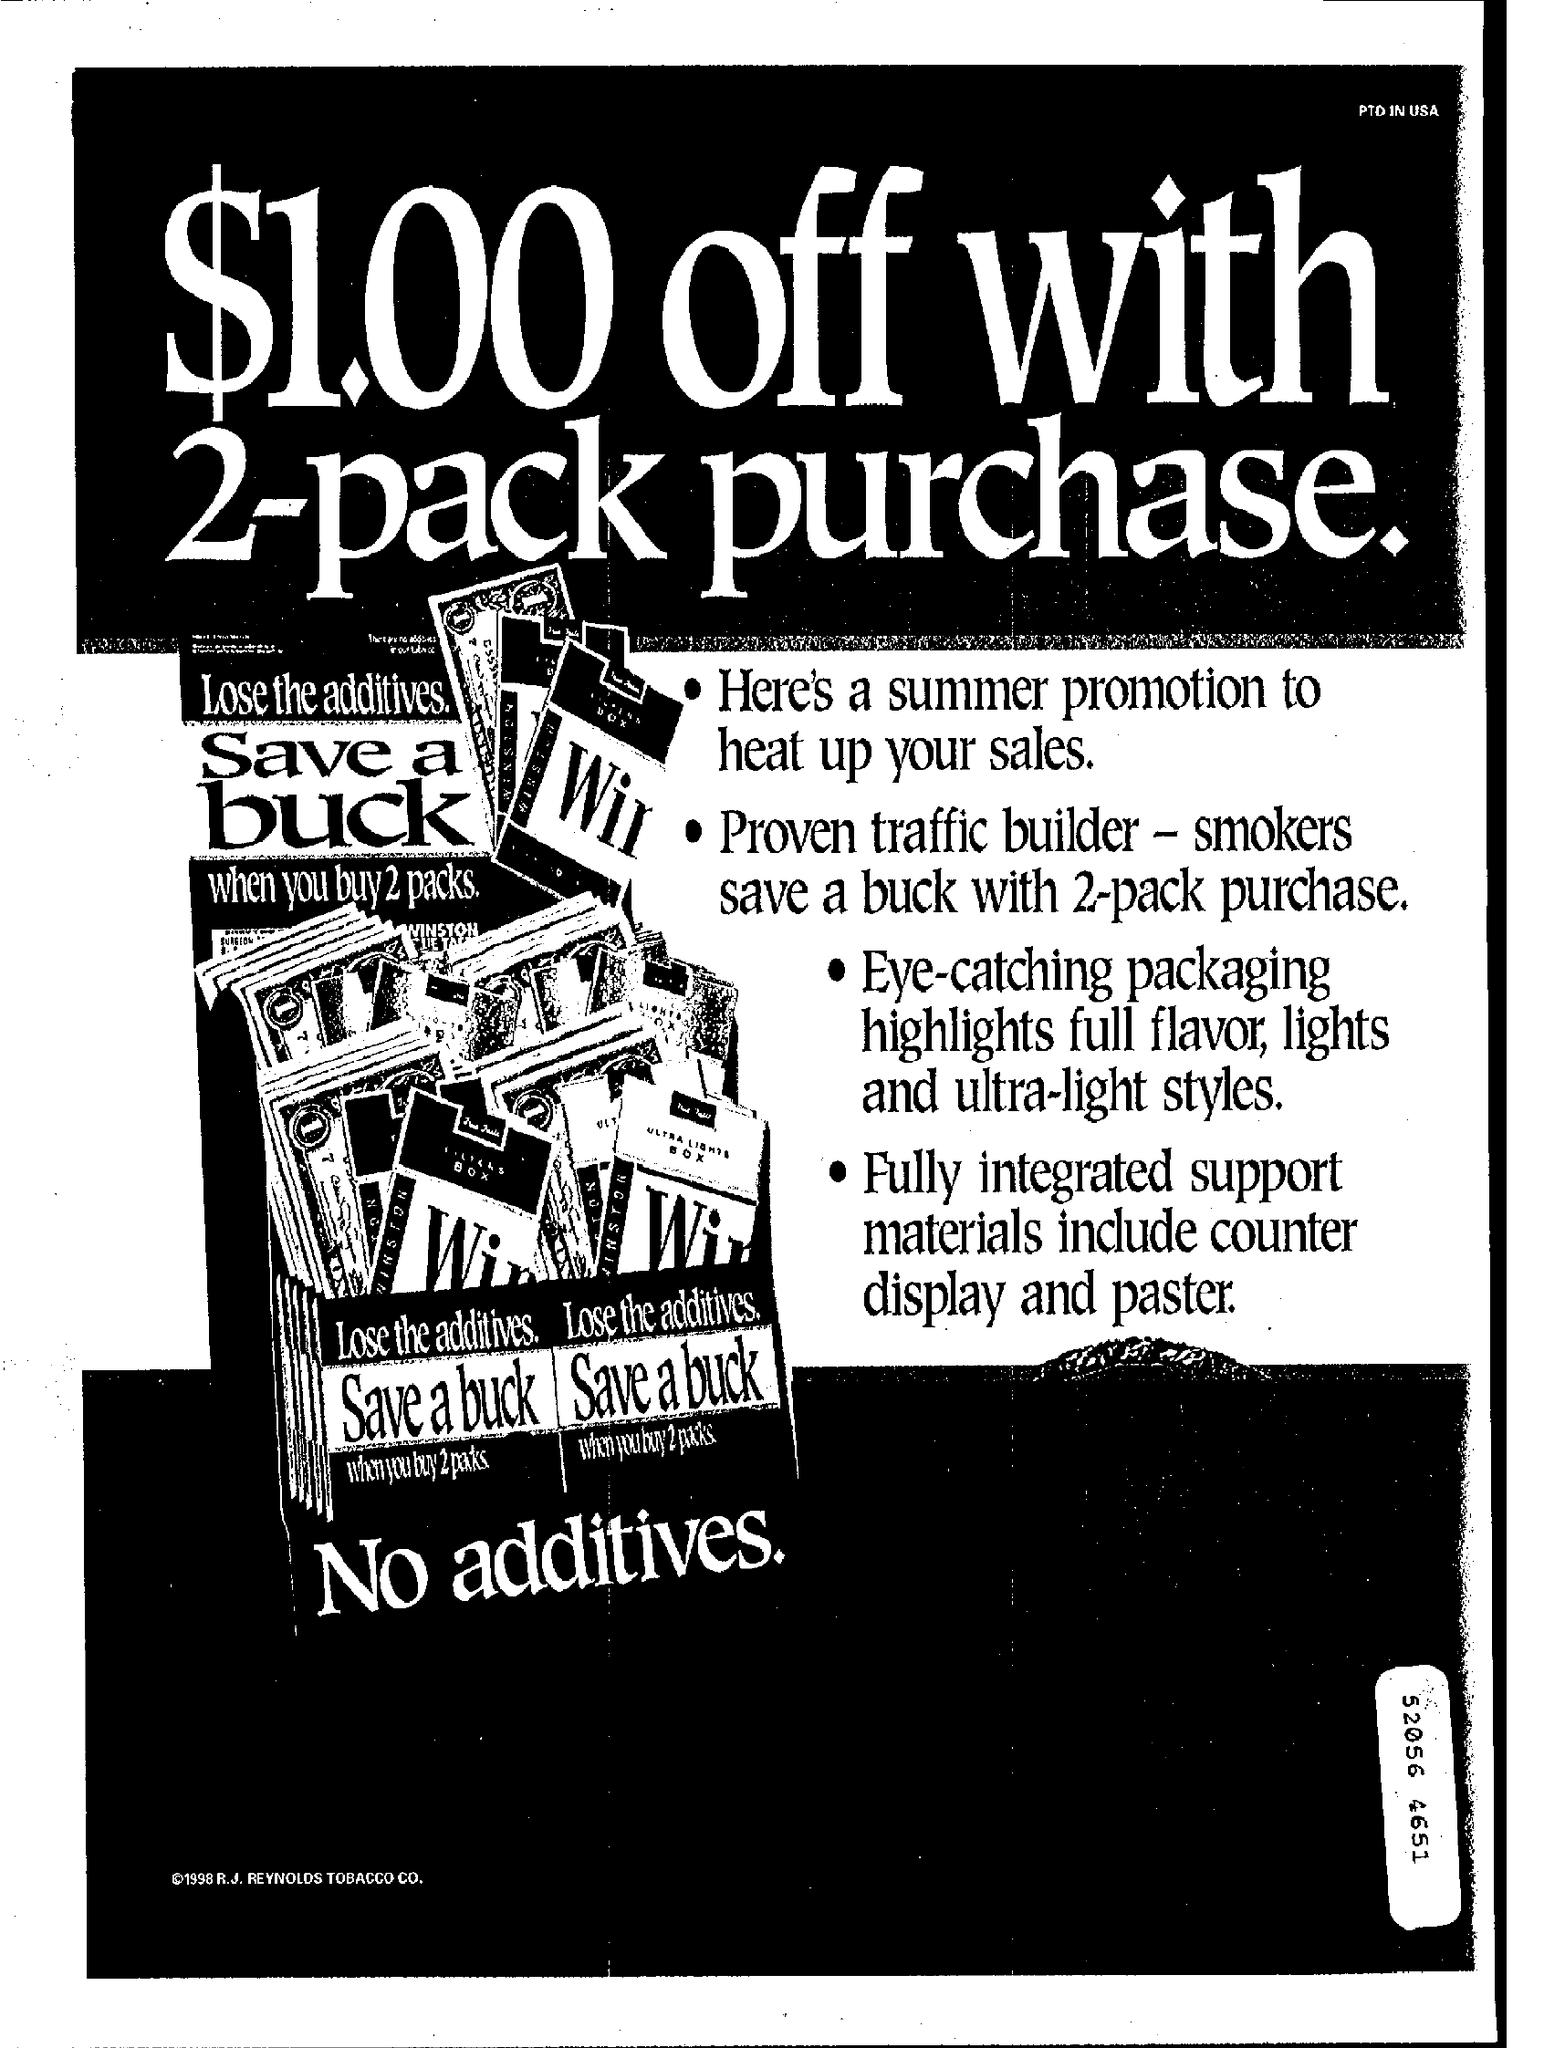Give some essential details in this illustration. The top-right corner of the document reads "PTD IN USA..", which indicates that the document appears to be related to the United States and may contain specific information regarding a design or product. The document is titled "What is the title of the document? $1.00 off with 2-pack purchase... 